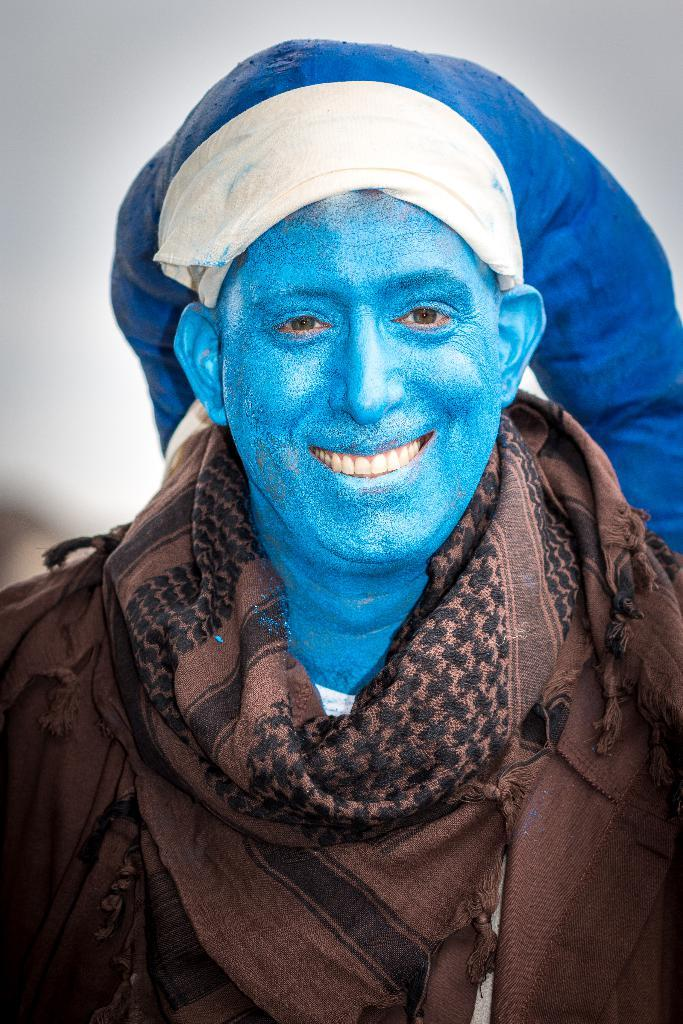Who is present in the image? There is a man in the image. What is the man doing in the image? The man is smiling in the image. What can be observed on the man's face? The man has blue color paint on his face. What type of tank can be seen in the background of the image? There is no tank visible in the image; it only features a man with blue paint on his face. 